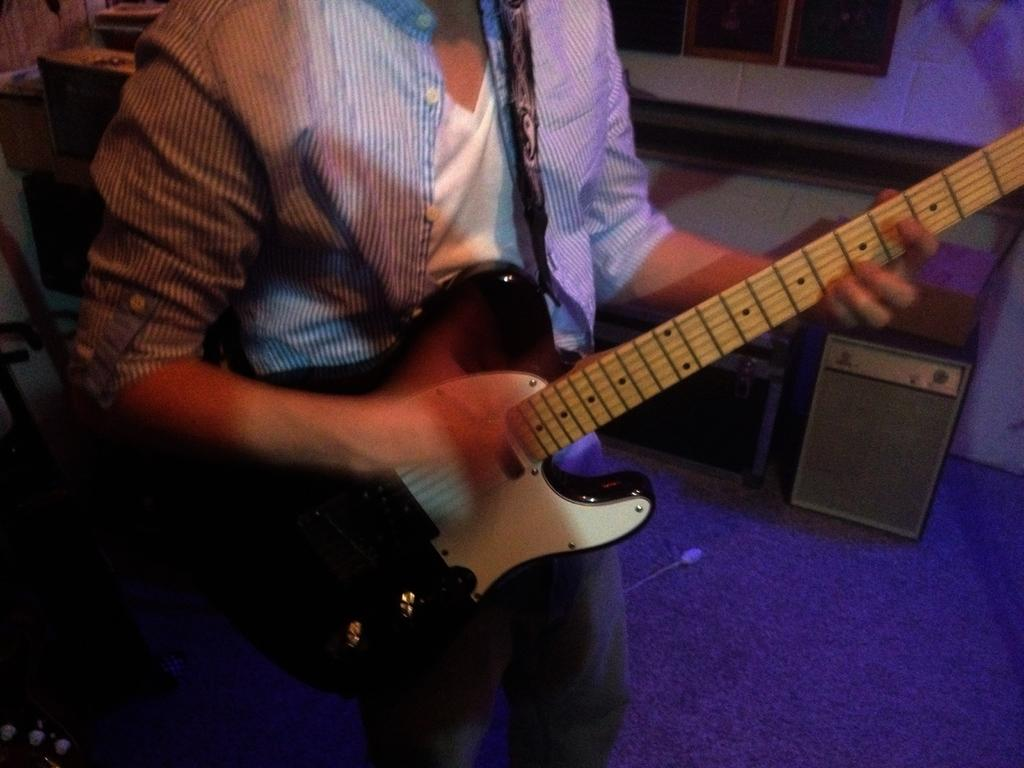What is the person in the image holding? The person is holding a guitar. What other objects or structures can be seen in the image? There is a table and a wall in the image. There is also a window near the wall. Can you describe the setting where the person is located? The person is likely in a room, given the presence of a table, wall, and window. Reasoning: Let's think step by identifying the main subject in the image, which is the person holding a guitar. Then, we expand the conversation to include other objects and structures that are also visible, such as the table, wall, and window. Each question is designed to elicit a specific detail about the image that is known from the provided facts. We avoid yes/no questions and ensure that the language is simple and clear. Absurd Question/Answer: What type of honey is being used to tune the guitar in the image? There is no honey present in the image, and the guitar is not being tuned. 